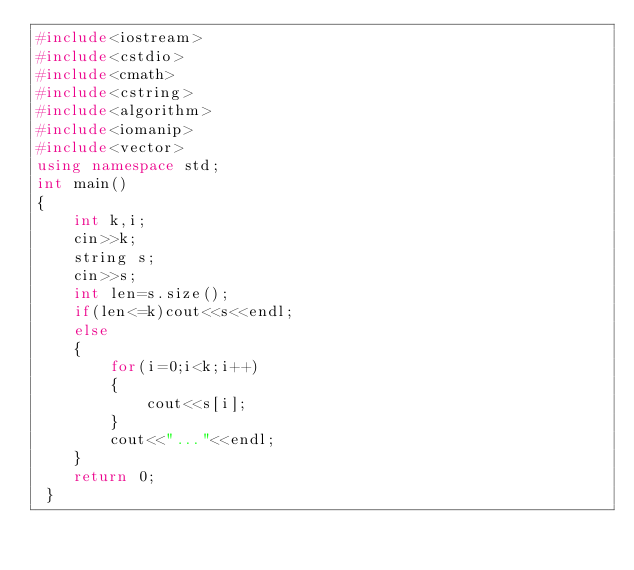Convert code to text. <code><loc_0><loc_0><loc_500><loc_500><_C++_>#include<iostream>
#include<cstdio>
#include<cmath>
#include<cstring>
#include<algorithm>
#include<iomanip>
#include<vector>
using namespace std;
int main()
{
	int k,i;
	cin>>k;
	string s;
	cin>>s;
	int len=s.size();
	if(len<=k)cout<<s<<endl;
	else 
	{
		for(i=0;i<k;i++)
		{
			cout<<s[i];
		}
		cout<<"..."<<endl;
	}
	return 0;
 } </code> 